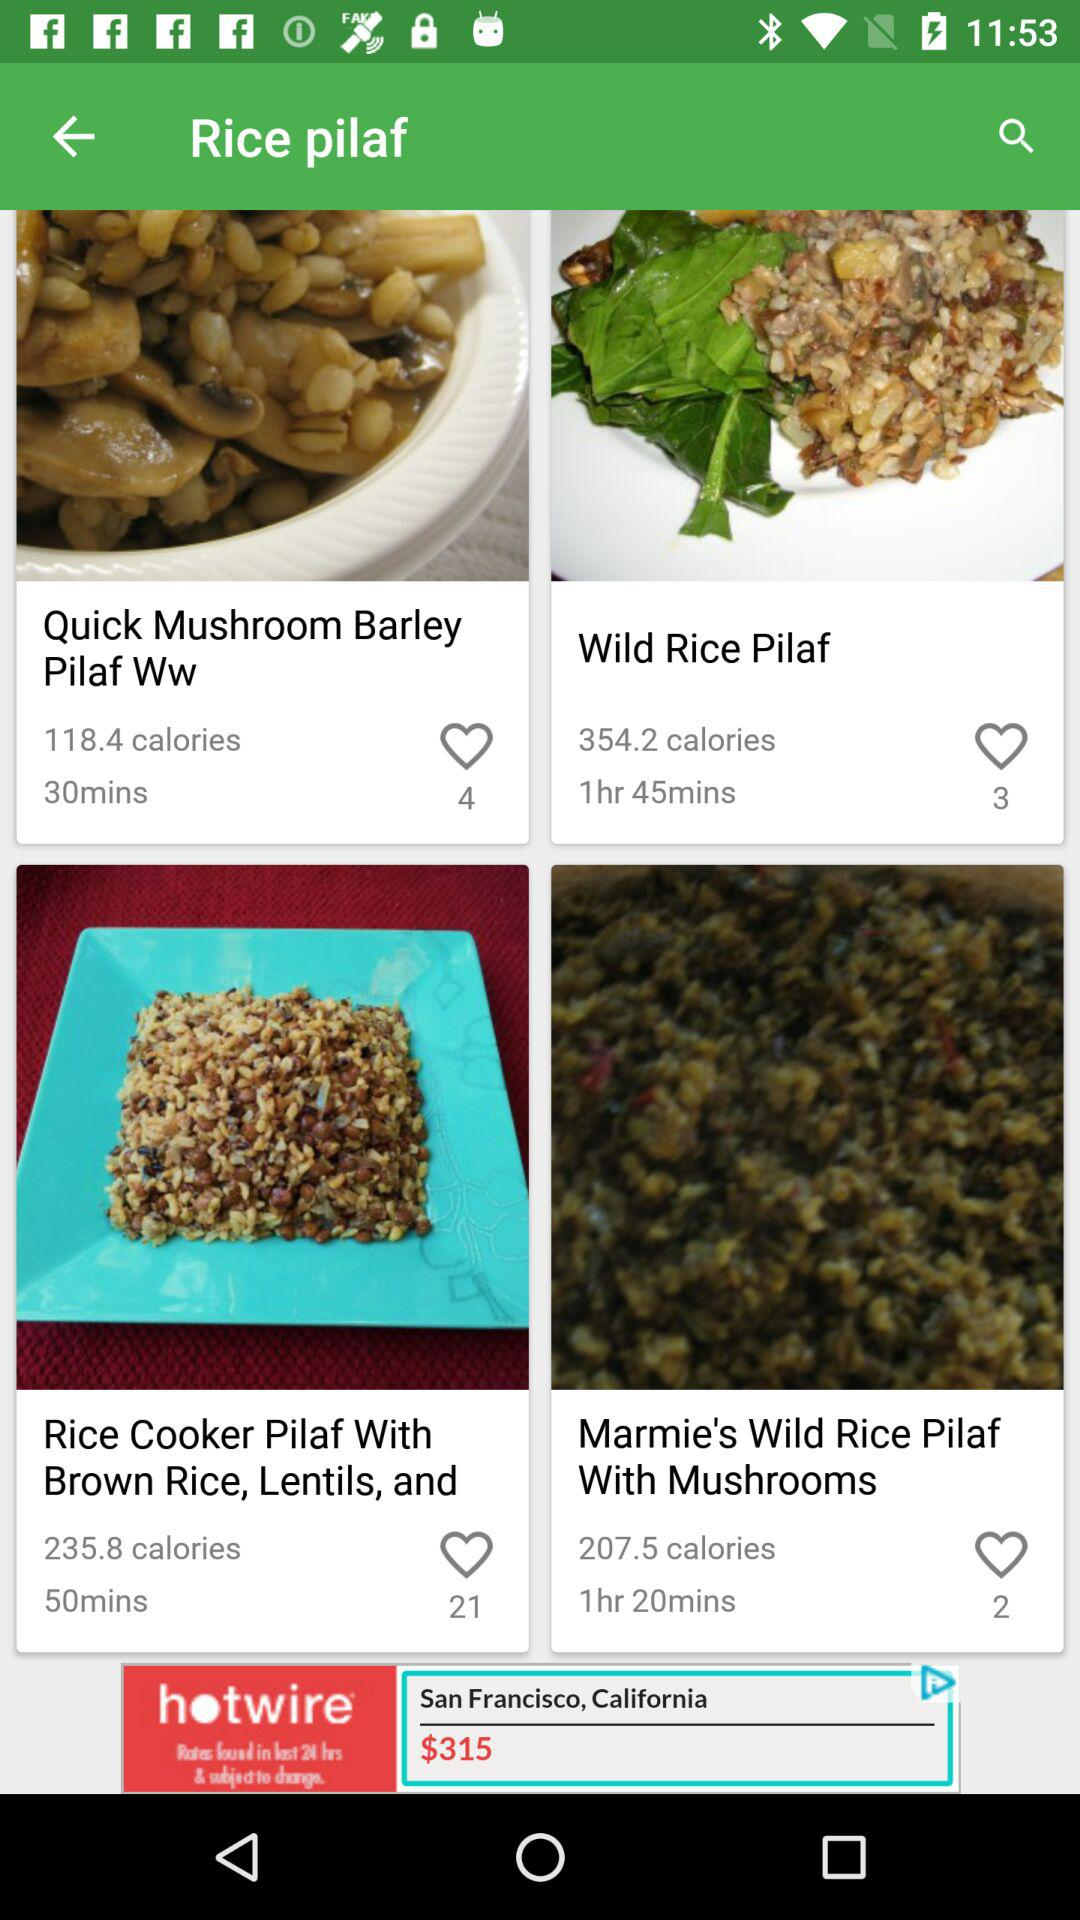How many more calories are there in the Wild Rice Pilaf than in the Quick Mushroom Barley Pilaf?
Answer the question using a single word or phrase. 235.8 